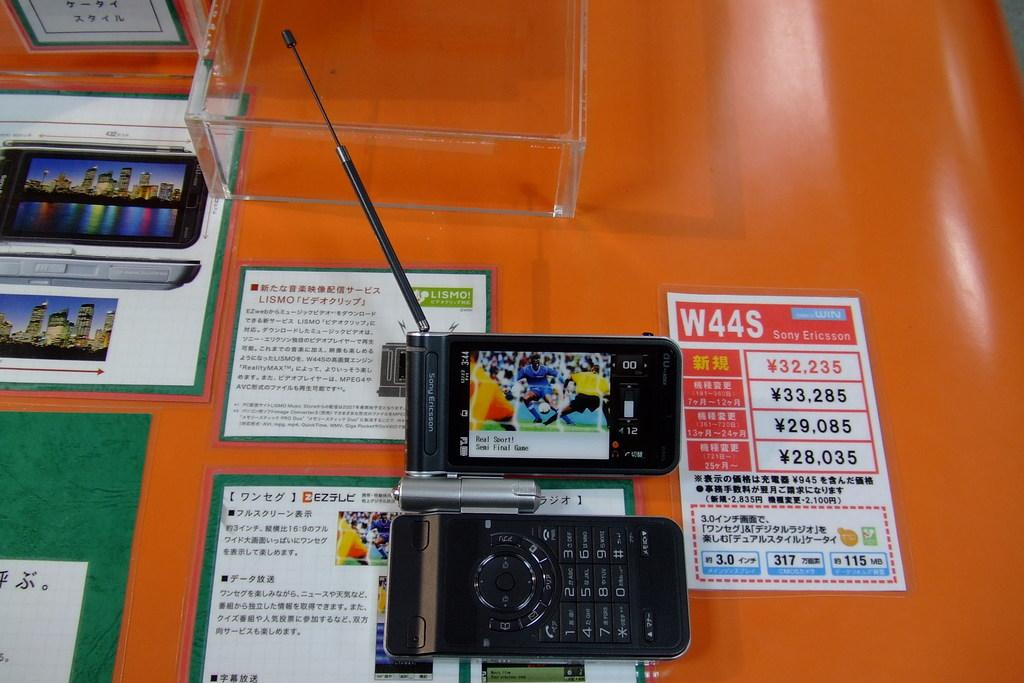<image>
Relay a brief, clear account of the picture shown. A Sony Ericcson phone and another device sitting on an orange table. 